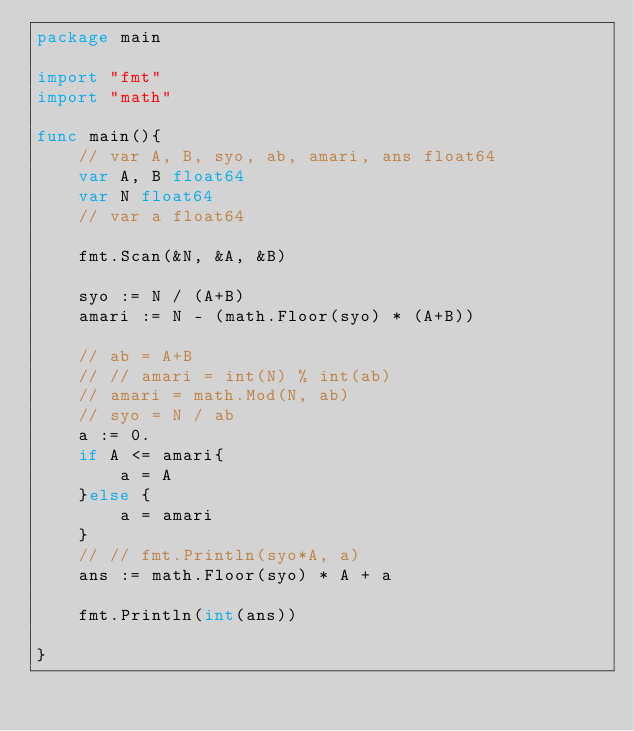<code> <loc_0><loc_0><loc_500><loc_500><_Go_>package main

import "fmt"
import "math"

func main(){
	// var A, B, syo, ab, amari, ans float64
	var A, B float64
	var N float64
	// var a float64

	fmt.Scan(&N, &A, &B)

	syo := N / (A+B)
	amari := N - (math.Floor(syo) * (A+B))

	// ab = A+B
	// // amari = int(N) % int(ab)
	// amari = math.Mod(N, ab)
	// syo = N / ab
	a := 0.
	if A <= amari{
		a = A
	}else {
		a = amari
	}
	// // fmt.Println(syo*A, a)
	ans := math.Floor(syo) * A + a

	fmt.Println(int(ans))

}</code> 